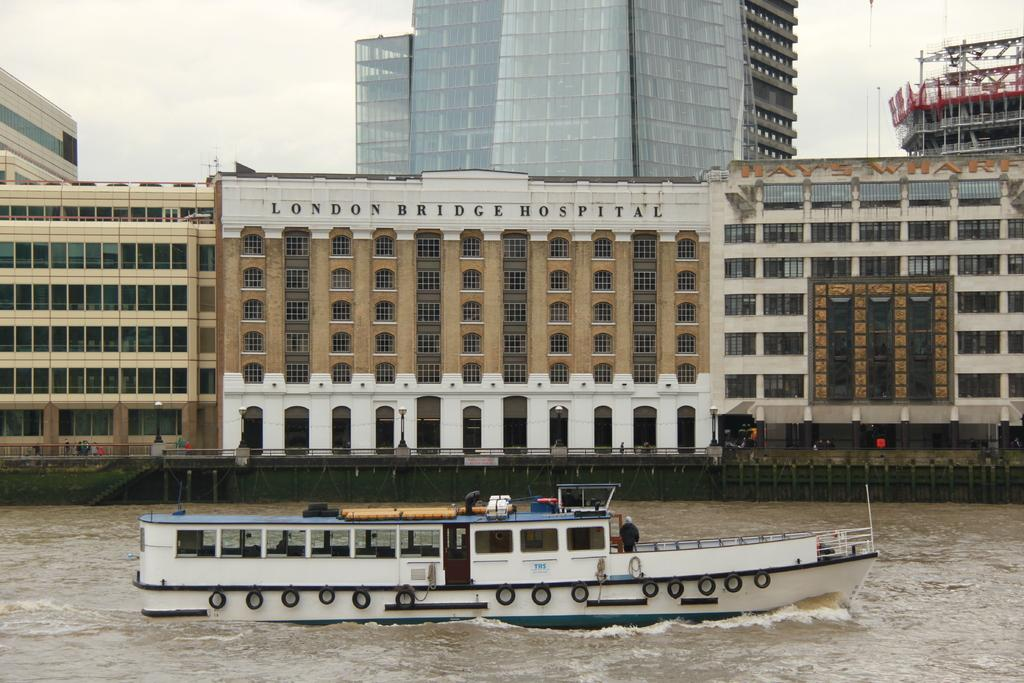<image>
Provide a brief description of the given image. A boat cruising on a river, passing the London Bridge Hospital. 